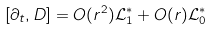Convert formula to latex. <formula><loc_0><loc_0><loc_500><loc_500>[ \partial _ { t } , D ] = O ( r ^ { 2 } ) \mathcal { L } ^ { * } _ { 1 } + O ( r ) \mathcal { L } ^ { * } _ { 0 }</formula> 